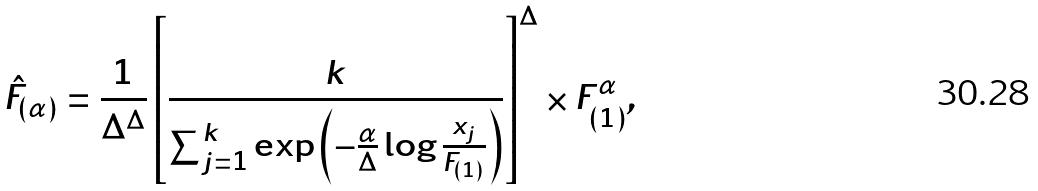<formula> <loc_0><loc_0><loc_500><loc_500>\hat { F } _ { ( \alpha ) } = \frac { 1 } { \Delta ^ { \Delta } } \left [ \frac { k } { \sum _ { j = 1 } ^ { k } \exp \left ( - \frac { \alpha } { \Delta } \log \frac { x _ { j } } { F _ { ( 1 ) } } \right ) } \right ] ^ { \Delta } \times F _ { ( 1 ) } ^ { \alpha } ,</formula> 